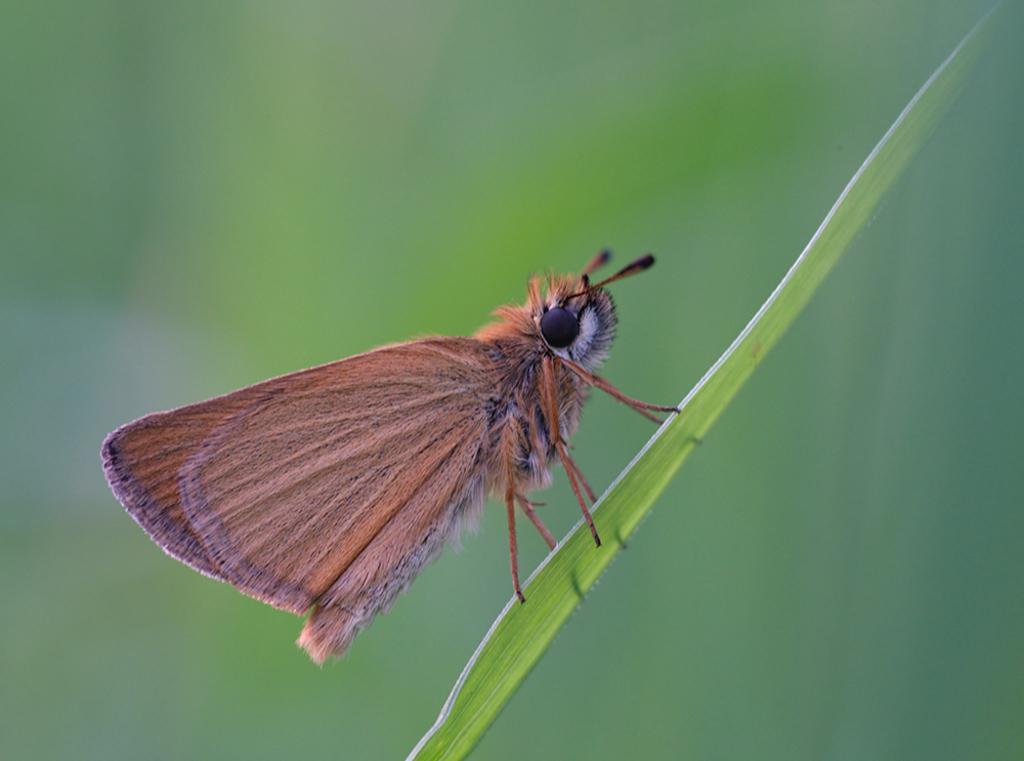How would you summarize this image in a sentence or two? In this image, I can see a butterfly standing on a leaf. 